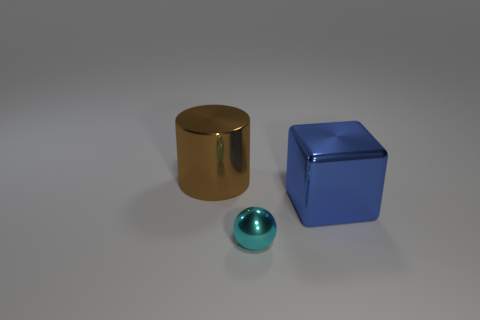Add 3 big blocks. How many objects exist? 6 Subtract all balls. How many objects are left? 2 Add 3 small cyan cylinders. How many small cyan cylinders exist? 3 Subtract 0 green spheres. How many objects are left? 3 Subtract all cylinders. Subtract all cyan things. How many objects are left? 1 Add 1 cyan shiny things. How many cyan shiny things are left? 2 